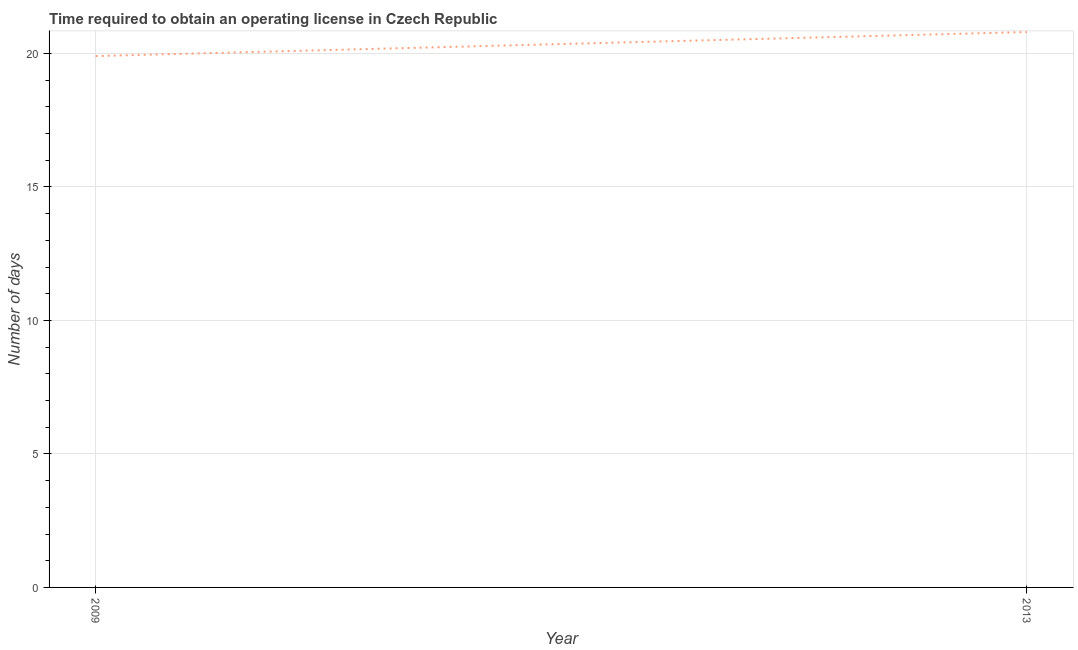What is the number of days to obtain operating license in 2013?
Offer a very short reply. 20.8. Across all years, what is the maximum number of days to obtain operating license?
Provide a short and direct response. 20.8. Across all years, what is the minimum number of days to obtain operating license?
Provide a short and direct response. 19.9. What is the sum of the number of days to obtain operating license?
Your answer should be compact. 40.7. What is the difference between the number of days to obtain operating license in 2009 and 2013?
Offer a very short reply. -0.9. What is the average number of days to obtain operating license per year?
Give a very brief answer. 20.35. What is the median number of days to obtain operating license?
Your answer should be compact. 20.35. In how many years, is the number of days to obtain operating license greater than 5 days?
Keep it short and to the point. 2. What is the ratio of the number of days to obtain operating license in 2009 to that in 2013?
Your response must be concise. 0.96. Is the number of days to obtain operating license in 2009 less than that in 2013?
Your response must be concise. Yes. In how many years, is the number of days to obtain operating license greater than the average number of days to obtain operating license taken over all years?
Provide a short and direct response. 1. Does the number of days to obtain operating license monotonically increase over the years?
Your answer should be very brief. Yes. What is the difference between two consecutive major ticks on the Y-axis?
Keep it short and to the point. 5. Are the values on the major ticks of Y-axis written in scientific E-notation?
Your answer should be compact. No. Does the graph contain any zero values?
Offer a terse response. No. What is the title of the graph?
Provide a short and direct response. Time required to obtain an operating license in Czech Republic. What is the label or title of the X-axis?
Keep it short and to the point. Year. What is the label or title of the Y-axis?
Your answer should be very brief. Number of days. What is the Number of days in 2009?
Give a very brief answer. 19.9. What is the Number of days of 2013?
Offer a terse response. 20.8. What is the difference between the Number of days in 2009 and 2013?
Make the answer very short. -0.9. What is the ratio of the Number of days in 2009 to that in 2013?
Make the answer very short. 0.96. 